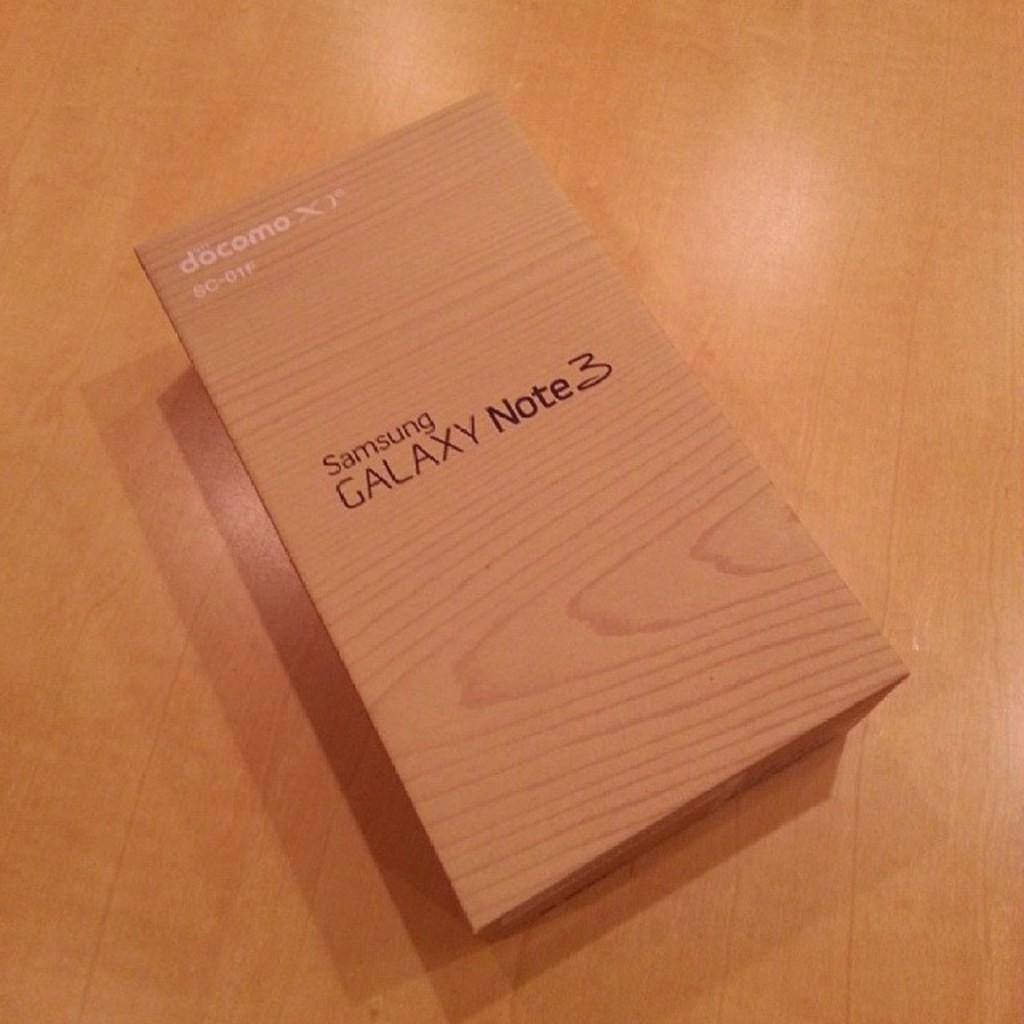<image>
Share a concise interpretation of the image provided. a wooden colored box that is labeled 'samsung galaxy note 3' 